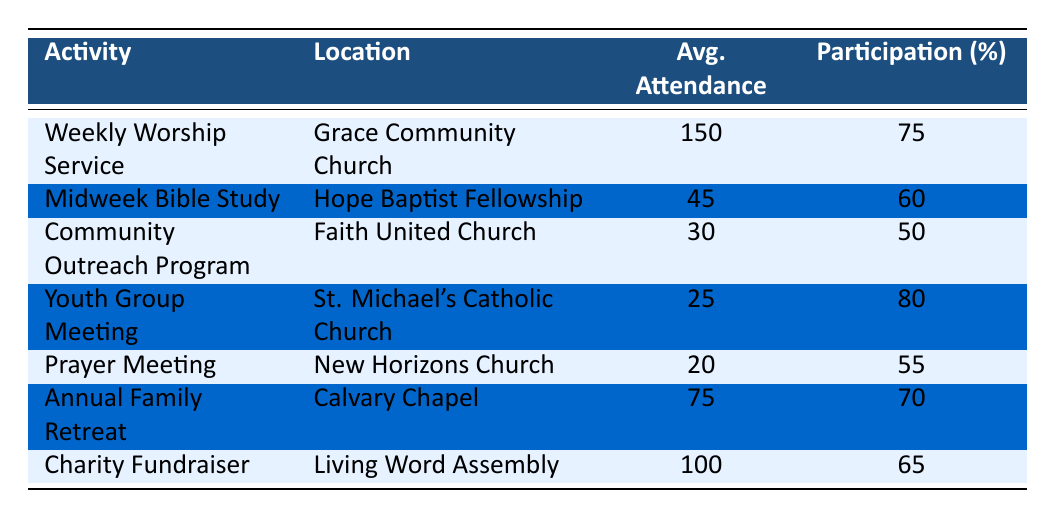What is the average attendance for the Weekly Worship Service? The table indicates that the average attendance for the Weekly Worship Service at Grace Community Church is listed as 150.
Answer: 150 Which activity had the lowest average attendance? By comparing the 'Avg. Attendance' column, the lowest value is for the Youth Group Meeting at St. Michael's Catholic Church with an average attendance of 25.
Answer: Youth Group Meeting What is the total average attendance for all the activities listed? To find the total average attendance, sum all the average attendance values: 150 + 45 + 30 + 25 + 20 + 75 + 100 = 445.
Answer: 445 Is the average participation rate for the Annual Family Retreat greater than 60%? The average participation for the Annual Family Retreat is noted as 70%, which is indeed greater than 60%.
Answer: Yes What is the difference between the highest and lowest participation rates among the activities? The highest participation rate is 80% for the Youth Group Meeting and the lowest is 50% for the Community Outreach Program. The difference is calculated as 80 - 50 = 30.
Answer: 30 How many activities had an average attendance of over 50 participants? Looking through the 'Avg. Attendance' column, the activities with over 50 participants are: Weekly Worship Service (150), Charity Fundraiser (100), and Annual Family Retreat (75), totaling three activities.
Answer: 3 Which activity has the highest percentage of participation and what is that percentage? The Youth Group Meeting has the highest percentage of participation at 80%, as seen in the 'Participation (%)' column.
Answer: 80% Are more than half of the activities listed achieving a participation rate greater than or equal to 60%? Checking the participation percentages: Weekly Worship Service (75), Midweek Bible Study (60), Youth Group Meeting (80), Annual Family Retreat (70), Charity Fundraiser (65). That's 5 out of 7, which is more than half.
Answer: Yes What percentage of participants attend the Prayer Meeting relative to its average attendance? The Prayer Meeting has an average attendance of 20 with a participation percentage of 55%. To find the percentage of participants, multiply 20 (average attendance) by 55% (participation) to get 11 participants attending the meeting.
Answer: 11 participants 